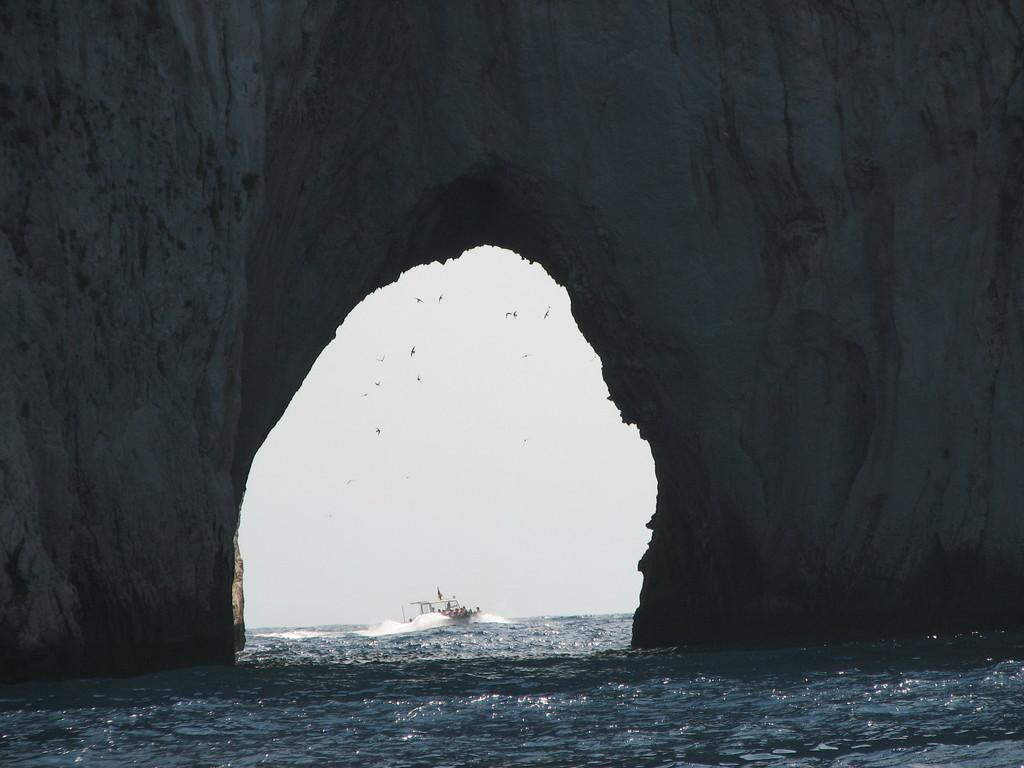What type of structure can be seen in the image? There is a tunnel in the image. What mode of transportation is present in the image? There is a boat in the image. What type of animals can be seen in the image? Birds can be seen in the image. What part of the natural environment is visible in the image? The sky and water are visible in the image. How many kittens are playing with the pipe in the image? There are no kittens or pipes present in the image. What type of spacecraft can be seen in the image? There is no spacecraft present in the image; it features a tunnel, a boat, birds, the sky, and water. 